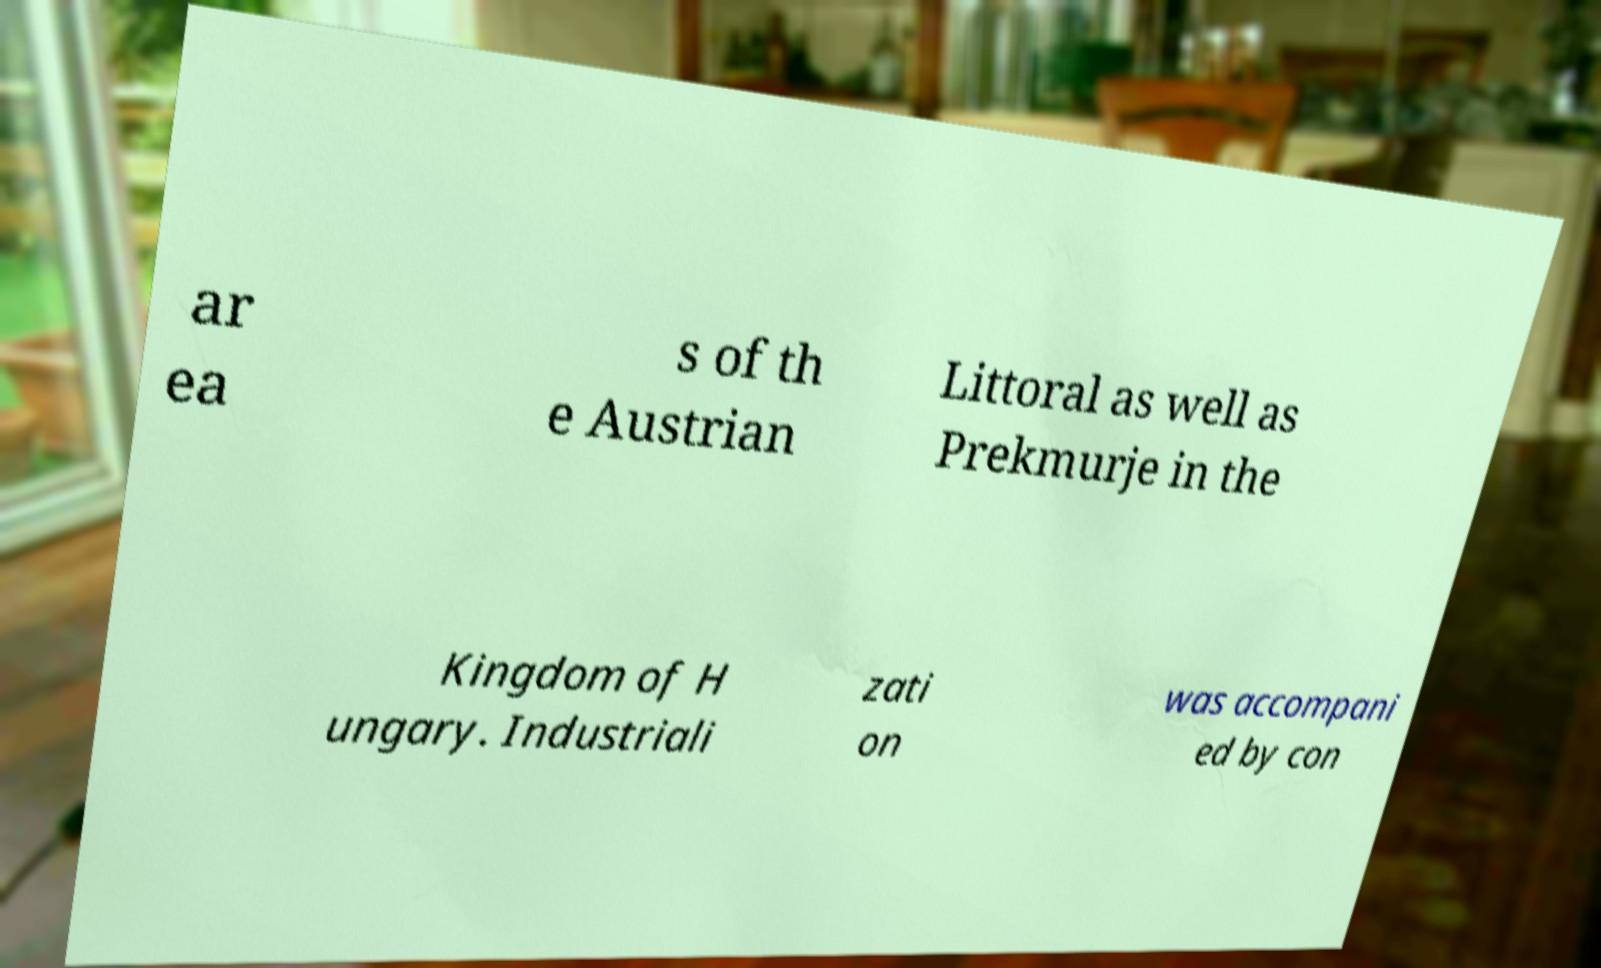I need the written content from this picture converted into text. Can you do that? ar ea s of th e Austrian Littoral as well as Prekmurje in the Kingdom of H ungary. Industriali zati on was accompani ed by con 